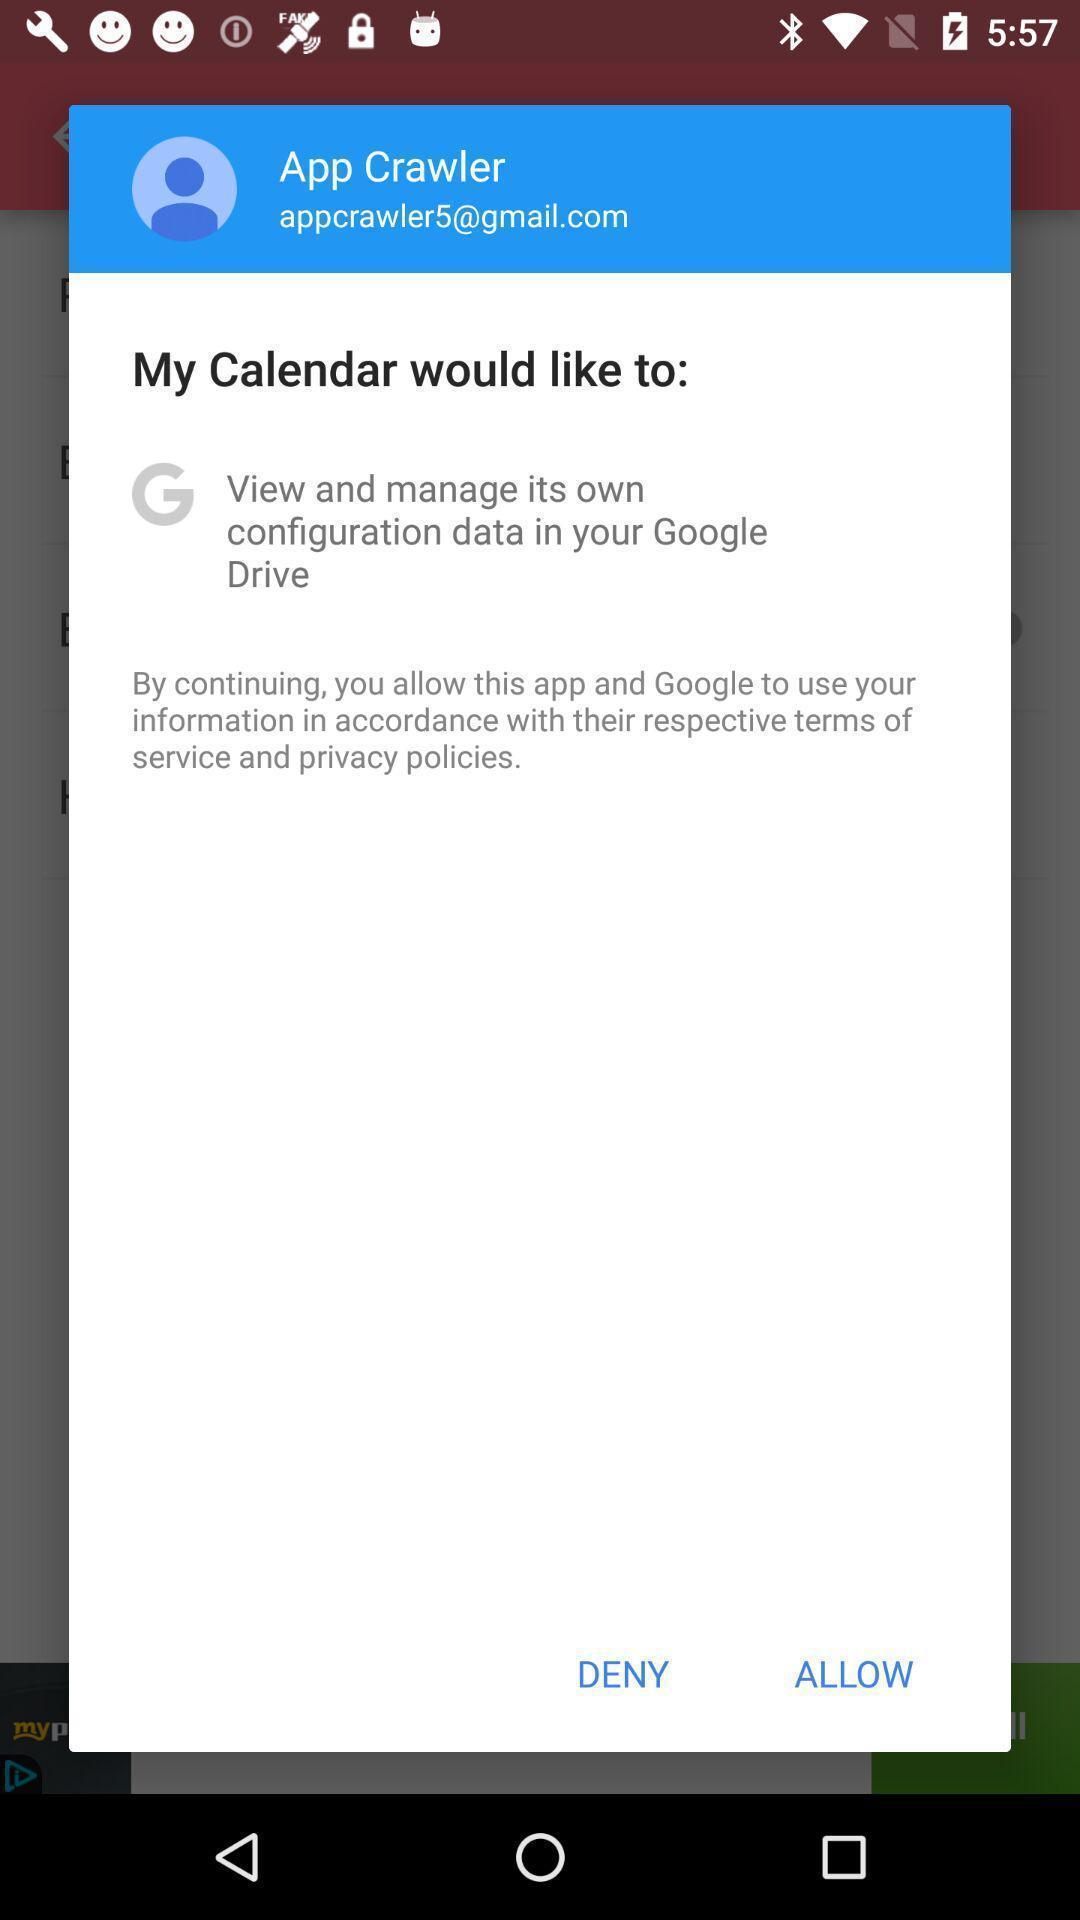What details can you identify in this image? Pop-up displaying the allow option for a social app. 